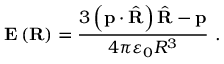<formula> <loc_0><loc_0><loc_500><loc_500>E \left ( R \right ) = { \frac { 3 \left ( p \cdot { \hat { R } } \right ) { \hat { R } } - p } { 4 \pi \varepsilon _ { 0 } R ^ { 3 } } } \ .</formula> 